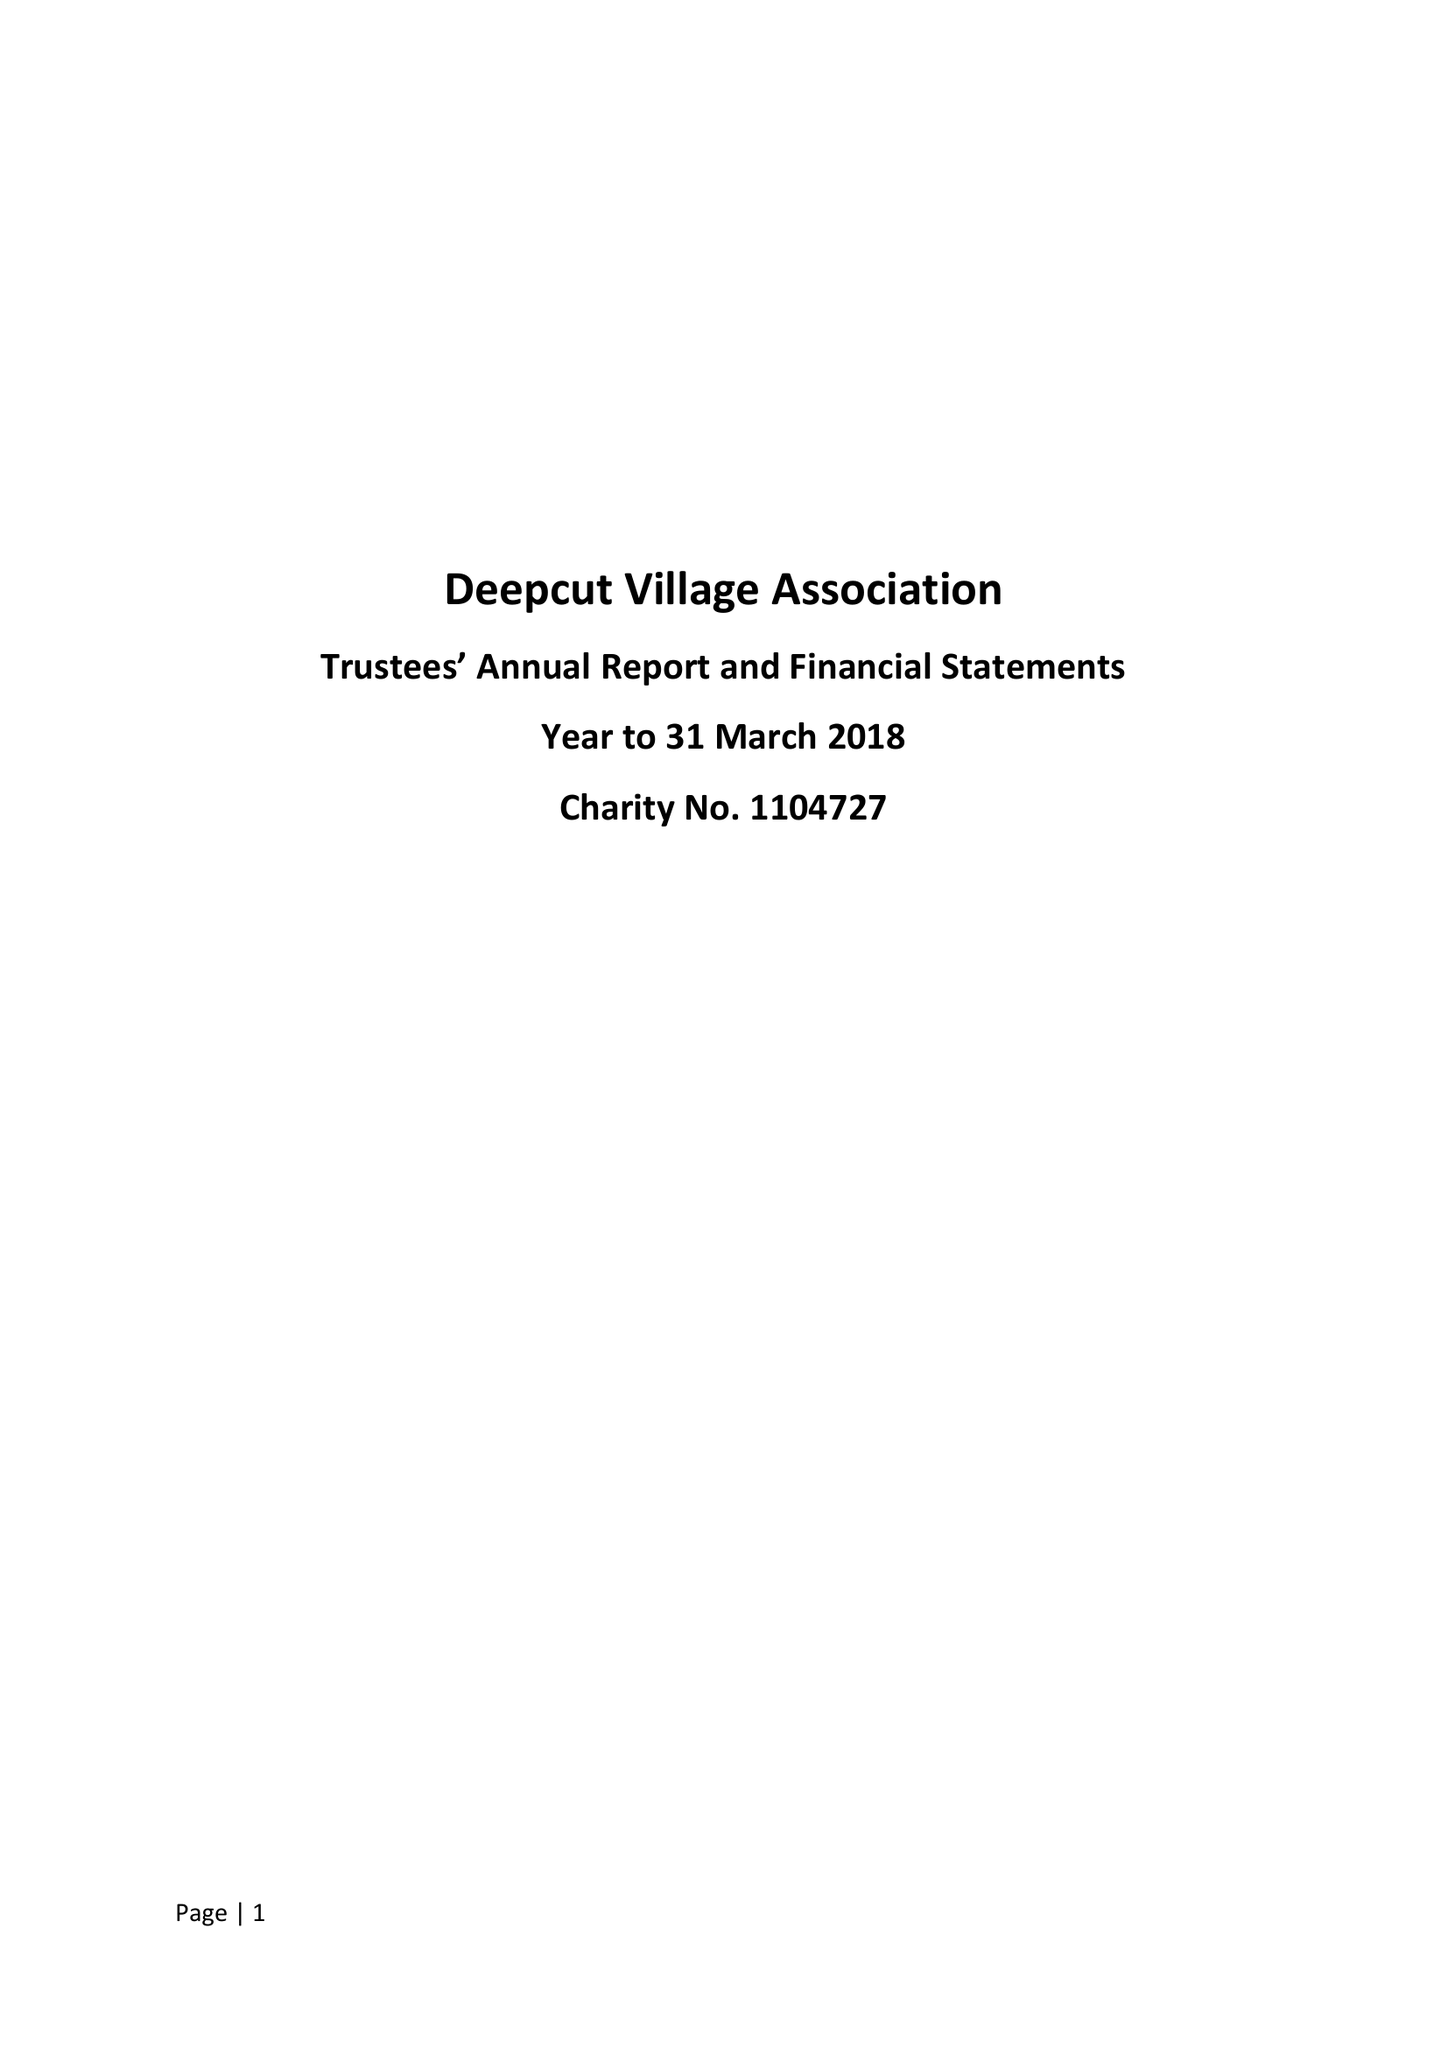What is the value for the charity_name?
Answer the question using a single word or phrase. Deepcut Village Association 